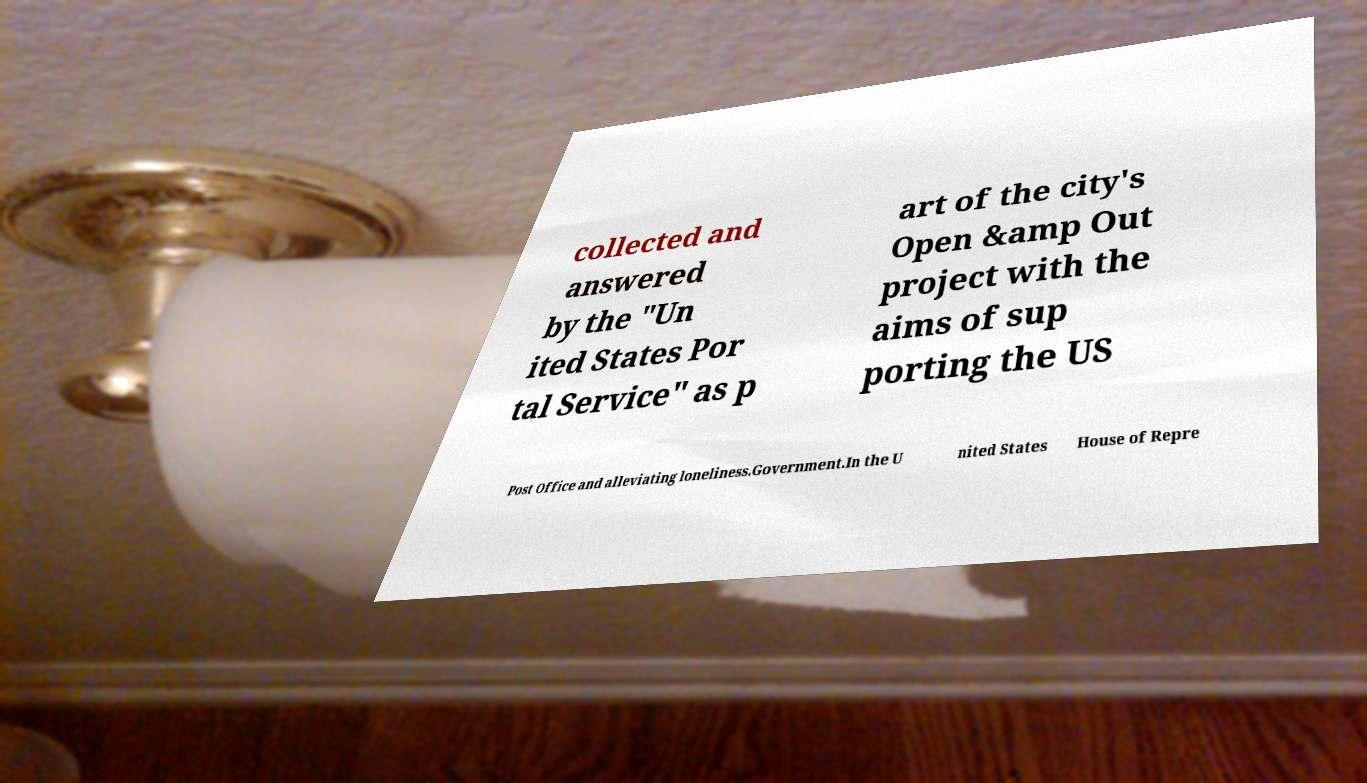Please identify and transcribe the text found in this image. collected and answered by the "Un ited States Por tal Service" as p art of the city's Open &amp Out project with the aims of sup porting the US Post Office and alleviating loneliness.Government.In the U nited States House of Repre 